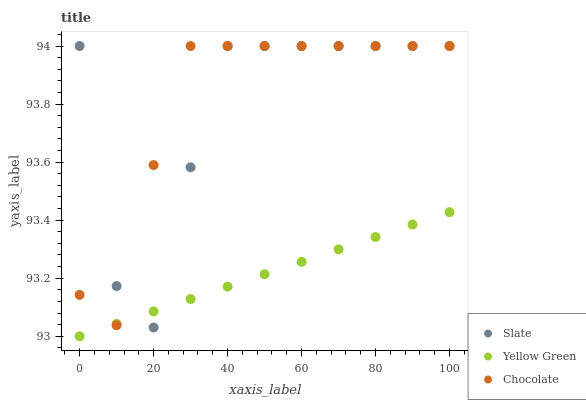Does Yellow Green have the minimum area under the curve?
Answer yes or no. Yes. Does Chocolate have the maximum area under the curve?
Answer yes or no. Yes. Does Chocolate have the minimum area under the curve?
Answer yes or no. No. Does Yellow Green have the maximum area under the curve?
Answer yes or no. No. Is Yellow Green the smoothest?
Answer yes or no. Yes. Is Slate the roughest?
Answer yes or no. Yes. Is Chocolate the smoothest?
Answer yes or no. No. Is Chocolate the roughest?
Answer yes or no. No. Does Yellow Green have the lowest value?
Answer yes or no. Yes. Does Chocolate have the lowest value?
Answer yes or no. No. Does Chocolate have the highest value?
Answer yes or no. Yes. Does Yellow Green have the highest value?
Answer yes or no. No. Does Chocolate intersect Yellow Green?
Answer yes or no. Yes. Is Chocolate less than Yellow Green?
Answer yes or no. No. Is Chocolate greater than Yellow Green?
Answer yes or no. No. 